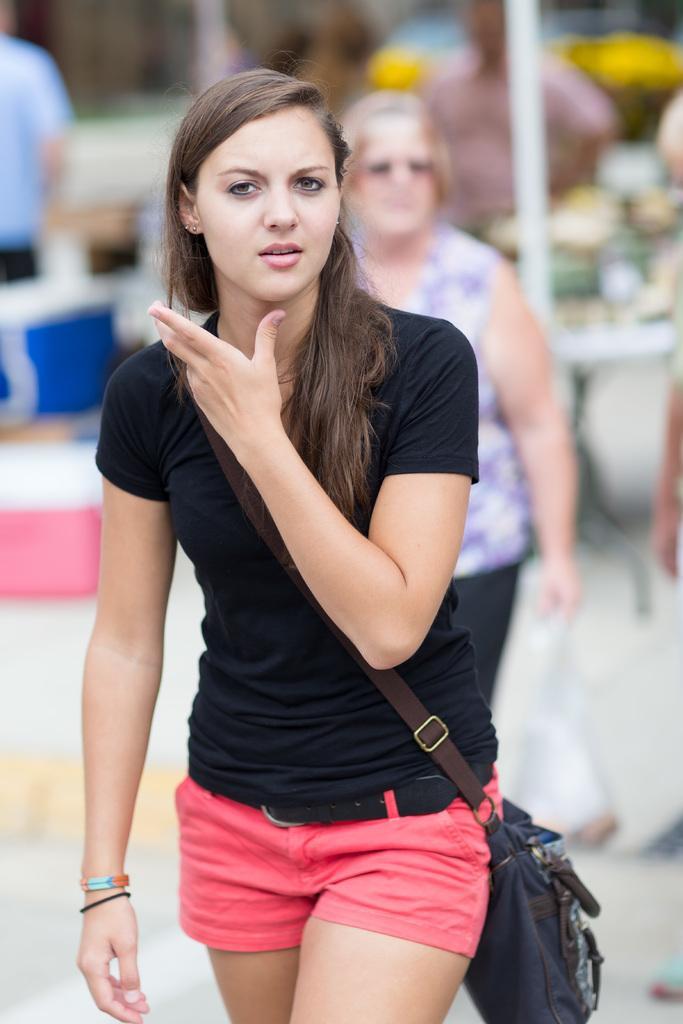How would you summarize this image in a sentence or two? In this image we can see a person walking and blur background. 